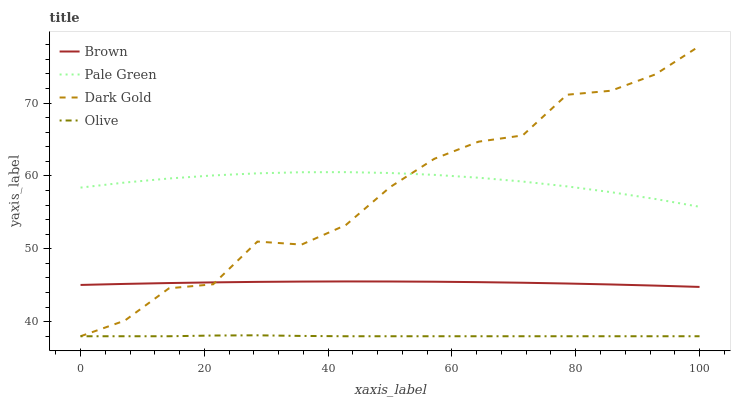Does Brown have the minimum area under the curve?
Answer yes or no. No. Does Brown have the maximum area under the curve?
Answer yes or no. No. Is Pale Green the smoothest?
Answer yes or no. No. Is Pale Green the roughest?
Answer yes or no. No. Does Brown have the lowest value?
Answer yes or no. No. Does Brown have the highest value?
Answer yes or no. No. Is Olive less than Brown?
Answer yes or no. Yes. Is Pale Green greater than Brown?
Answer yes or no. Yes. Does Olive intersect Brown?
Answer yes or no. No. 